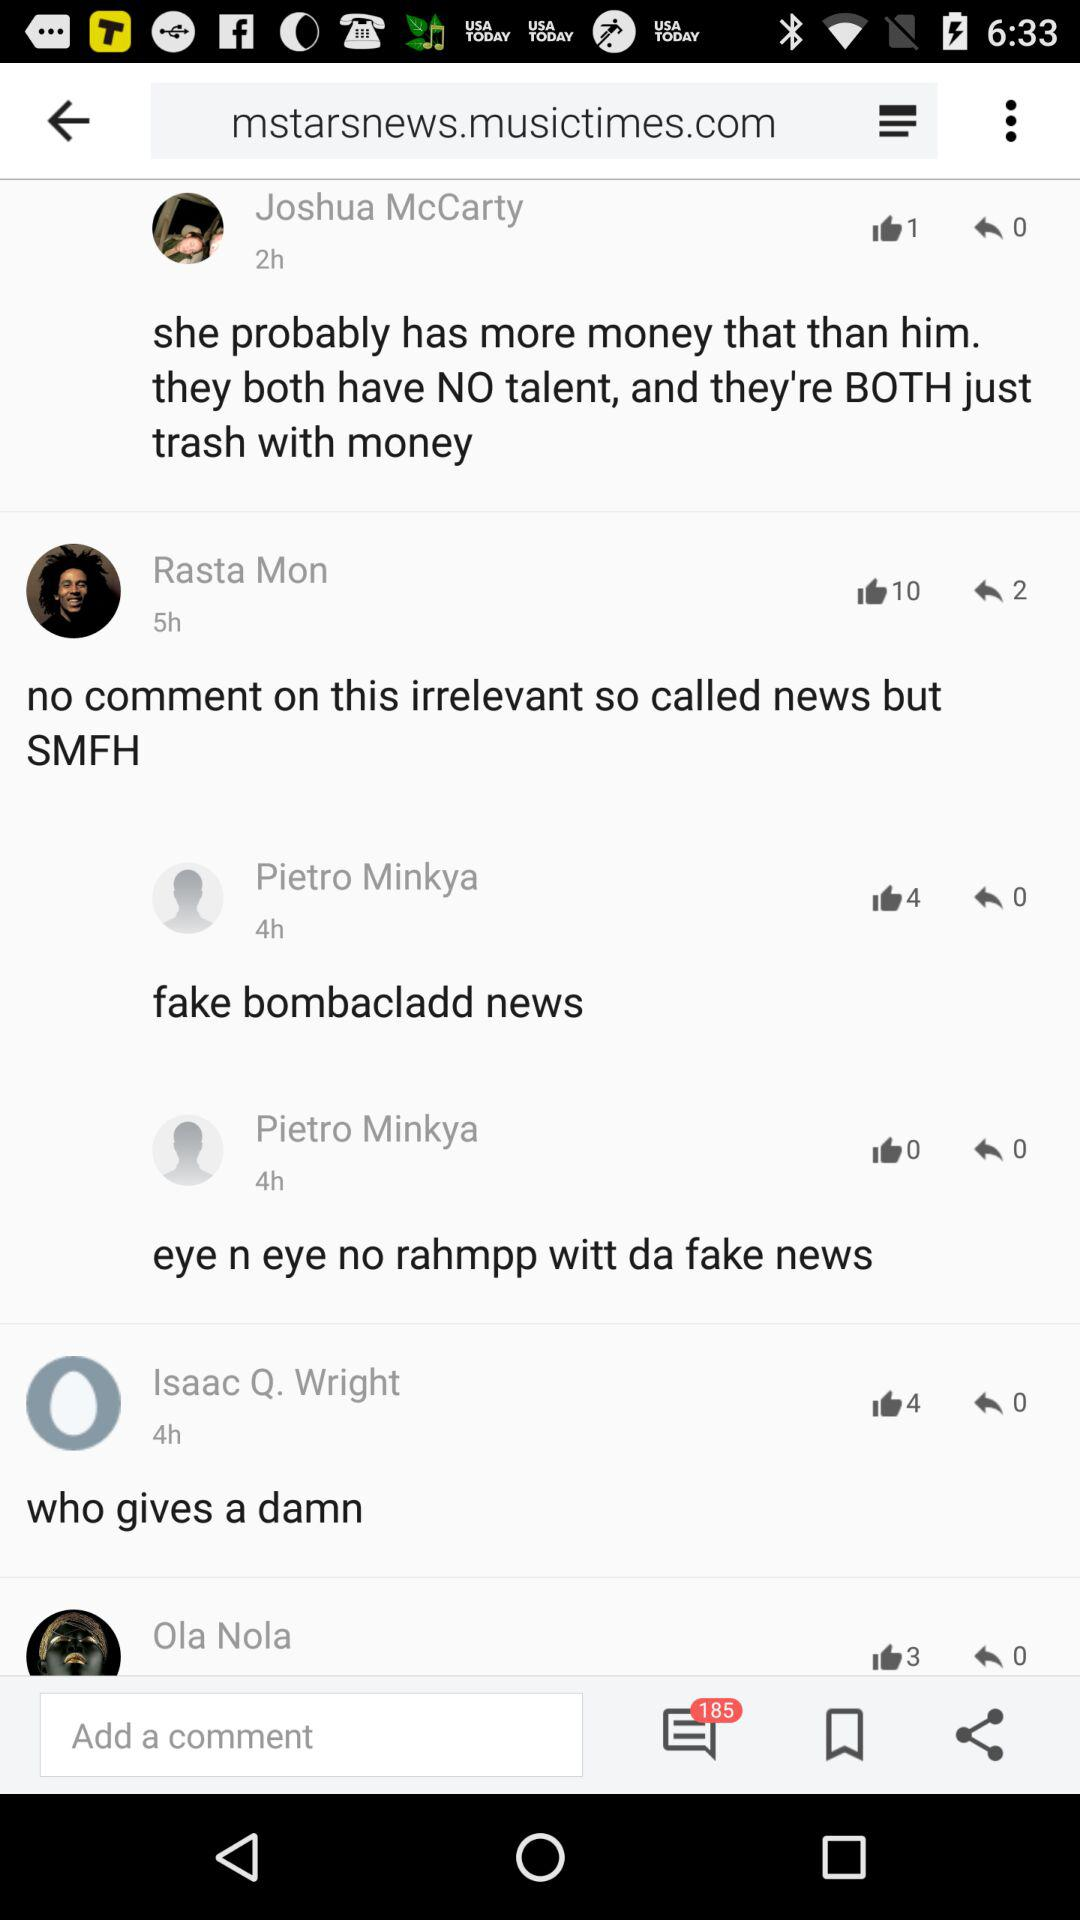What is the number of likes on Isaac Q. Wright's comment? The number of likes is 4. 